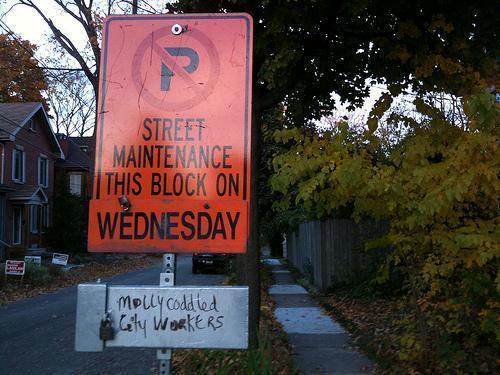How many sign posts are shown?
Give a very brief answer. 1. How many houses are visible?
Give a very brief answer. 2. How many vehicles are visible?
Give a very brief answer. 1. 